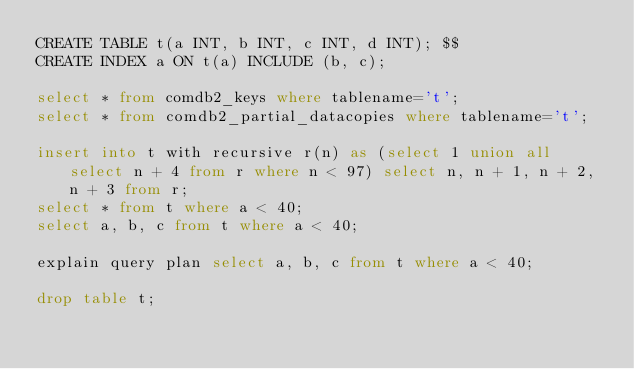<code> <loc_0><loc_0><loc_500><loc_500><_SQL_>CREATE TABLE t(a INT, b INT, c INT, d INT); $$
CREATE INDEX a ON t(a) INCLUDE (b, c);

select * from comdb2_keys where tablename='t';
select * from comdb2_partial_datacopies where tablename='t';

insert into t with recursive r(n) as (select 1 union all select n + 4 from r where n < 97) select n, n + 1, n + 2, n + 3 from r;
select * from t where a < 40;
select a, b, c from t where a < 40;

explain query plan select a, b, c from t where a < 40;

drop table t;
</code> 